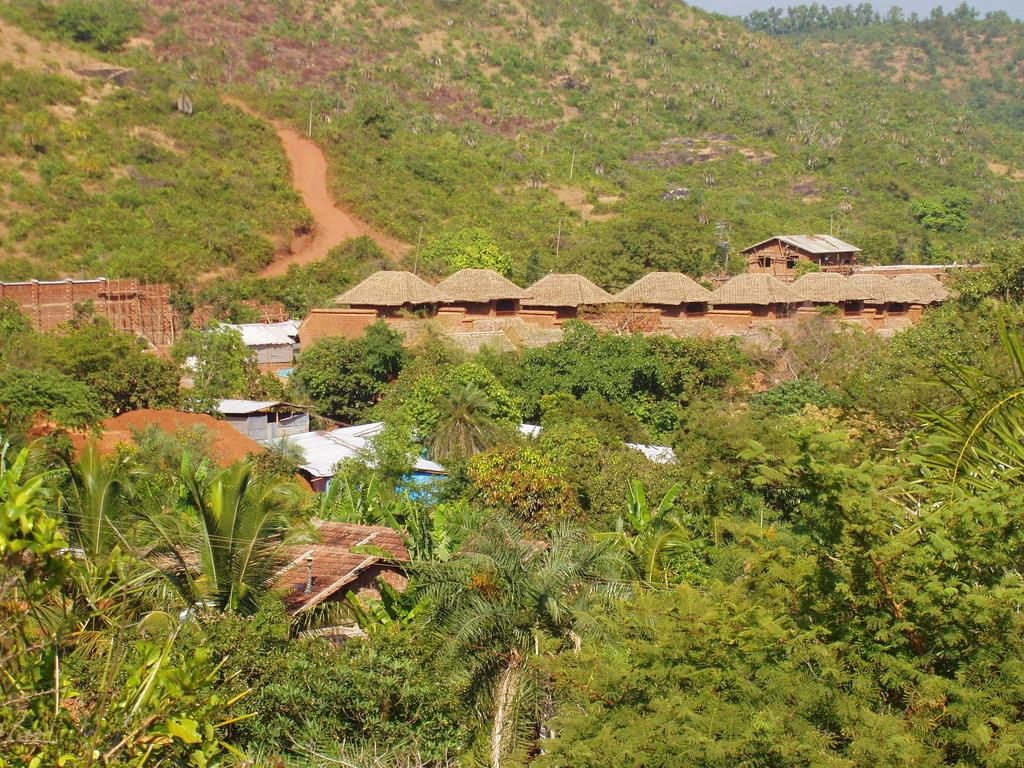What type of structures are present in the image? There are houses in the image. What other natural elements can be seen in the image? There are plants and trees in the image. What is visible in the background of the image? The sky is visible in the image. What thoughts are being exchanged during the meeting in the image? There is no meeting or thoughts present in the image; it features houses, plants, trees, and the sky. What type of tail can be seen on the plants in the image? There are no tails present on the plants in the image; they are simply plants and trees. 